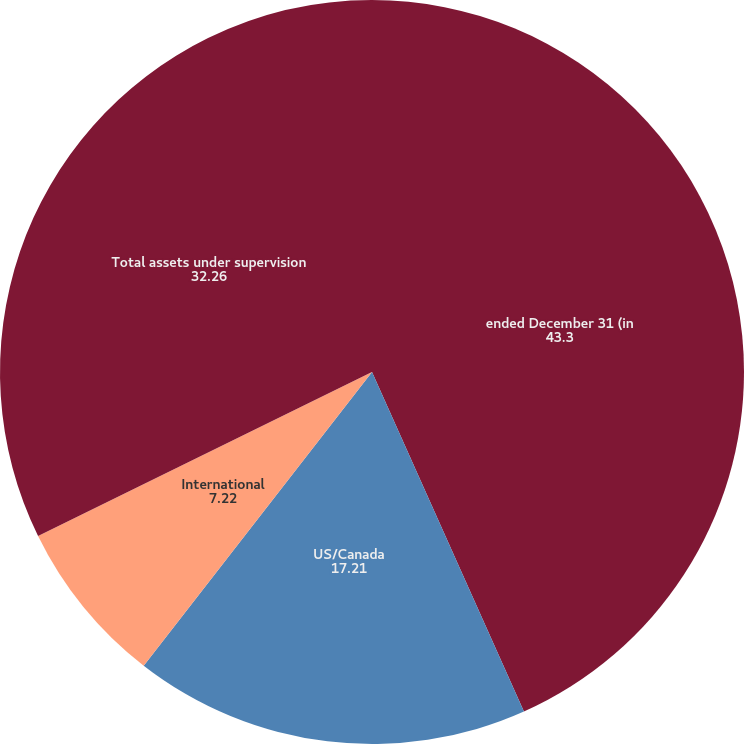Convert chart to OTSL. <chart><loc_0><loc_0><loc_500><loc_500><pie_chart><fcel>ended December 31 (in<fcel>US/Canada<fcel>International<fcel>Total assets under supervision<nl><fcel>43.3%<fcel>17.21%<fcel>7.22%<fcel>32.26%<nl></chart> 